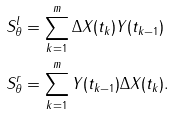Convert formula to latex. <formula><loc_0><loc_0><loc_500><loc_500>& S _ { \theta } ^ { l } = \sum _ { k = 1 } ^ { m } \Delta X ( t _ { k } ) Y ( t _ { k - 1 } ) \\ & S _ { \theta } ^ { r } = \sum _ { k = 1 } ^ { m } Y ( t _ { k - 1 } ) \Delta X ( t _ { k } ) .</formula> 